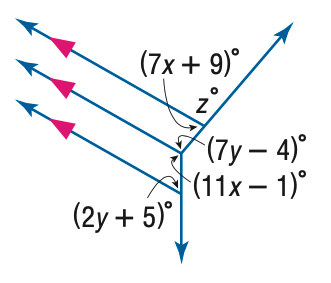Answer the mathemtical geometry problem and directly provide the correct option letter.
Question: Find y in the figure.
Choices: A: 11 B: 12 C: 13 D: 14 A 